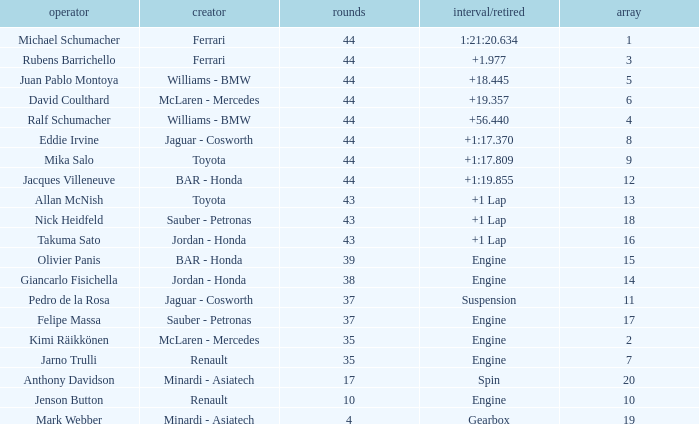What was the retired time on someone who had 43 laps on a grip of 18? +1 Lap. 